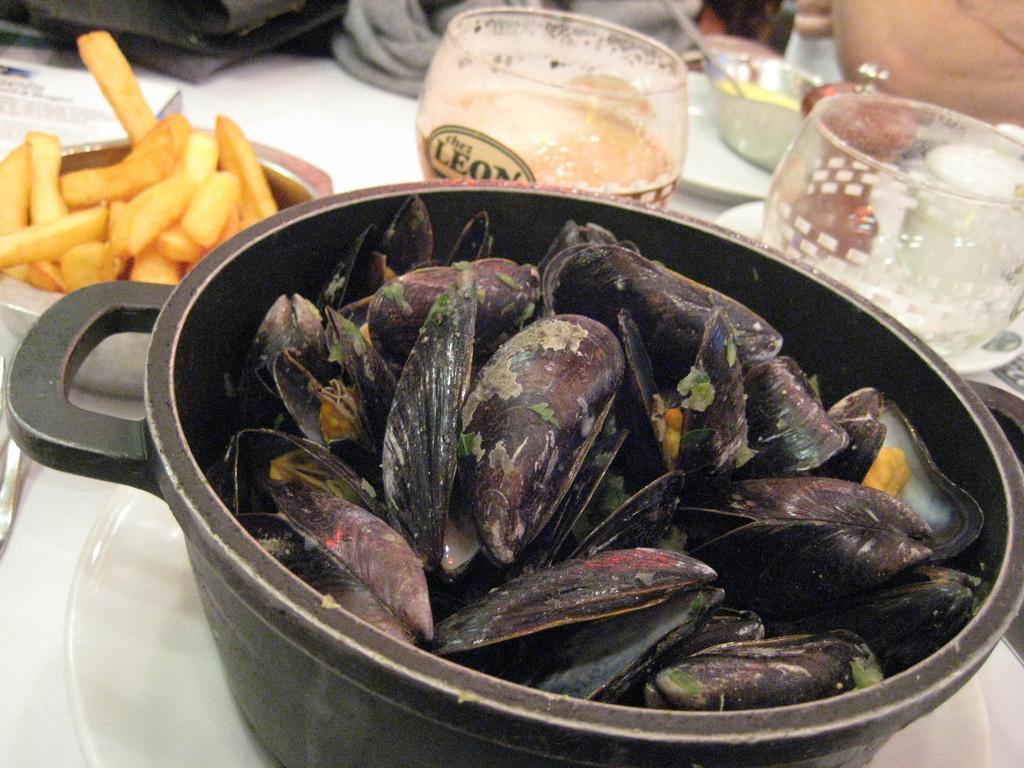How would you summarize this image in a sentence or two? In this image, we can see a bowl contains some sea shells. There is an another bowl on the left side of the image contains some food. There are glasses in the top right of the image. 